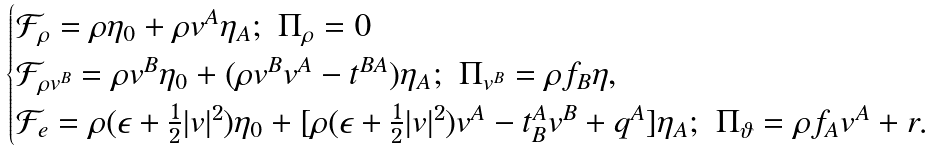<formula> <loc_0><loc_0><loc_500><loc_500>\begin{cases} \mathcal { F } _ { \rho } = \rho \eta _ { 0 } + \rho v ^ { A } \eta _ { A } ; \ \Pi _ { \rho } = 0 \\ \mathcal { F } _ { \rho v ^ { B } } = \rho v ^ { B } \eta _ { 0 } + ( \rho v ^ { B } v ^ { A } - t ^ { B A } ) \eta _ { A } ; \ \Pi _ { v ^ { B } } = \rho f _ { B } \eta , \\ \mathcal { F } _ { e } = \rho ( \epsilon + \frac { 1 } { 2 } | v | ^ { 2 } ) \eta _ { 0 } + [ \rho ( \epsilon + \frac { 1 } { 2 } | v | ^ { 2 } ) v ^ { A } - t ^ { A } _ { B } v ^ { B } + q ^ { A } ] \eta _ { A } ; \ \Pi _ { \vartheta } = \rho f _ { A } v ^ { A } + r . \end{cases}</formula> 